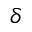<formula> <loc_0><loc_0><loc_500><loc_500>\delta</formula> 